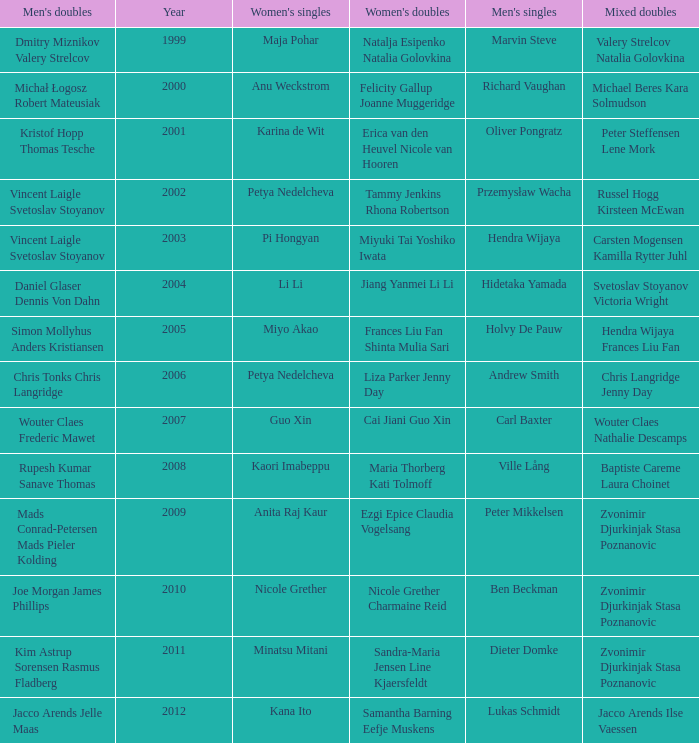What's the first year that Guo Xin featured in women's singles? 2007.0. 